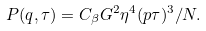<formula> <loc_0><loc_0><loc_500><loc_500>P ( q , \tau ) = C _ { \beta } G ^ { 2 } \eta ^ { 4 } ( p \tau ) ^ { 3 } / N .</formula> 